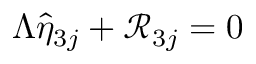Convert formula to latex. <formula><loc_0><loc_0><loc_500><loc_500>\Lambda \hat { \eta } _ { 3 j } + \mathcal { R } _ { 3 j } = 0</formula> 